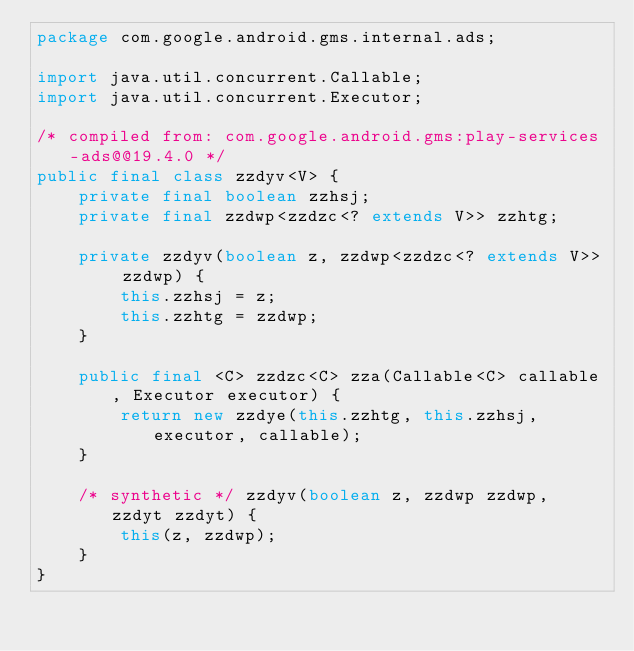Convert code to text. <code><loc_0><loc_0><loc_500><loc_500><_Java_>package com.google.android.gms.internal.ads;

import java.util.concurrent.Callable;
import java.util.concurrent.Executor;

/* compiled from: com.google.android.gms:play-services-ads@@19.4.0 */
public final class zzdyv<V> {
    private final boolean zzhsj;
    private final zzdwp<zzdzc<? extends V>> zzhtg;

    private zzdyv(boolean z, zzdwp<zzdzc<? extends V>> zzdwp) {
        this.zzhsj = z;
        this.zzhtg = zzdwp;
    }

    public final <C> zzdzc<C> zza(Callable<C> callable, Executor executor) {
        return new zzdye(this.zzhtg, this.zzhsj, executor, callable);
    }

    /* synthetic */ zzdyv(boolean z, zzdwp zzdwp, zzdyt zzdyt) {
        this(z, zzdwp);
    }
}
</code> 